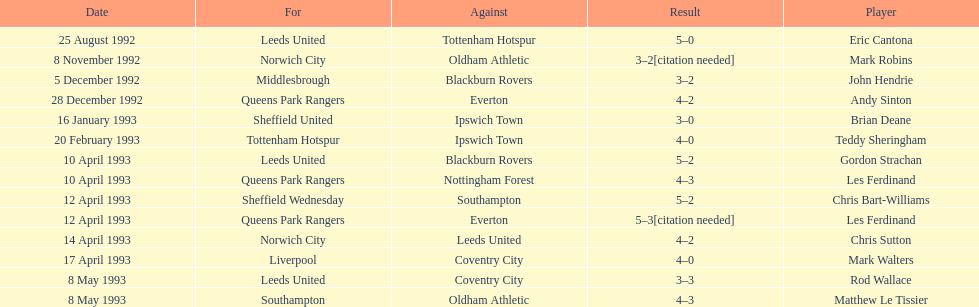In the 1992-1993 premier league, what was the total number of hat tricks scored by all players? 14. 